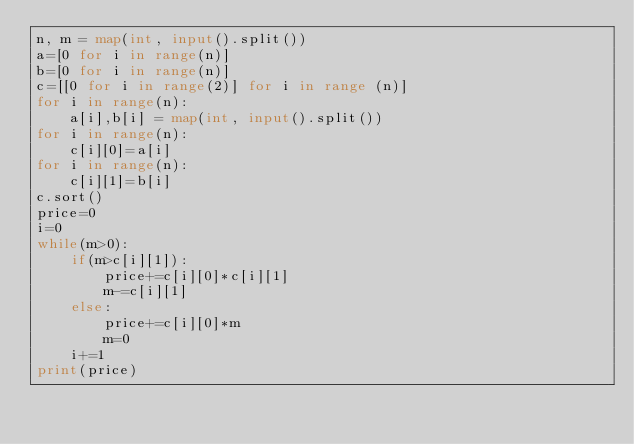Convert code to text. <code><loc_0><loc_0><loc_500><loc_500><_Python_>n, m = map(int, input().split())
a=[0 for i in range(n)]
b=[0 for i in range(n)]
c=[[0 for i in range(2)] for i in range (n)]
for i in range(n):
    a[i],b[i] = map(int, input().split())
for i in range(n):
    c[i][0]=a[i]
for i in range(n):
    c[i][1]=b[i]
c.sort()
price=0
i=0
while(m>0):
    if(m>c[i][1]):
        price+=c[i][0]*c[i][1]
        m-=c[i][1]
    else:
        price+=c[i][0]*m
        m=0
    i+=1
print(price)</code> 